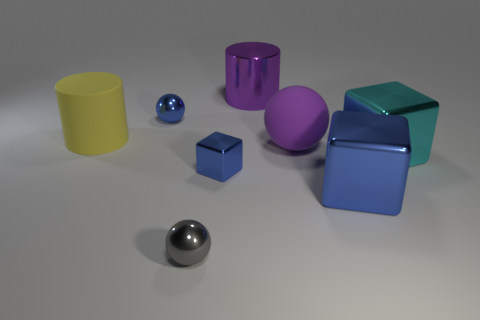What is the size of the blue metal cube that is on the left side of the big purple object that is behind the large rubber sphere?
Your answer should be very brief. Small. There is a thing that is both behind the cyan shiny cube and in front of the big yellow matte cylinder; what is its material?
Give a very brief answer. Rubber. Do the yellow matte cylinder and the cylinder that is to the right of the gray thing have the same size?
Ensure brevity in your answer.  Yes. Is there a small cyan metal block?
Your answer should be compact. No. There is a big yellow thing that is the same shape as the large purple shiny thing; what is its material?
Your response must be concise. Rubber. There is a ball that is behind the rubber ball that is behind the small sphere in front of the matte cylinder; what size is it?
Your answer should be very brief. Small. There is a big rubber sphere; are there any tiny blue things on the left side of it?
Your answer should be compact. Yes. What size is the other blue block that is the same material as the large blue block?
Ensure brevity in your answer.  Small. How many small gray metallic things have the same shape as the big purple matte thing?
Offer a very short reply. 1. Do the tiny block and the big purple object in front of the blue shiny sphere have the same material?
Provide a short and direct response. No. 